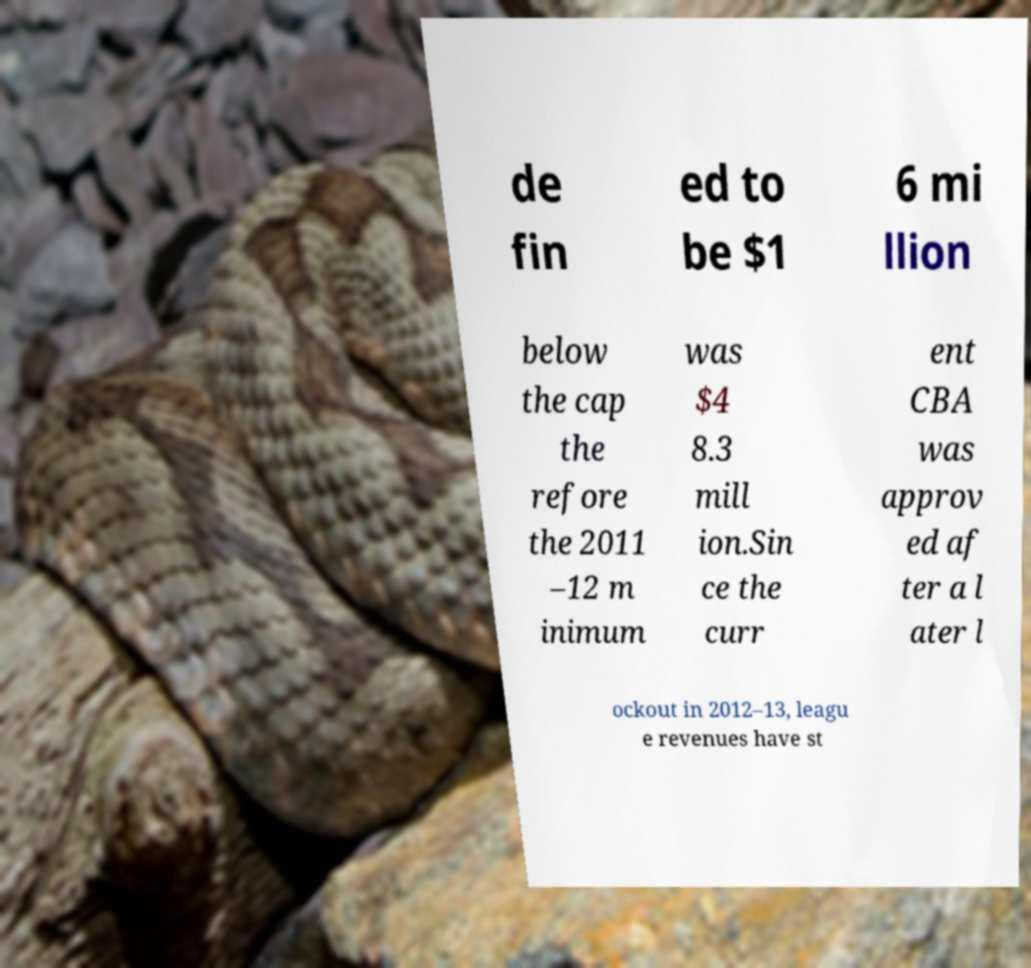Could you assist in decoding the text presented in this image and type it out clearly? de fin ed to be $1 6 mi llion below the cap the refore the 2011 –12 m inimum was $4 8.3 mill ion.Sin ce the curr ent CBA was approv ed af ter a l ater l ockout in 2012–13, leagu e revenues have st 